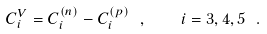<formula> <loc_0><loc_0><loc_500><loc_500>C _ { i } ^ { V } = C _ { i } ^ { ( n ) } - C _ { i } ^ { ( p ) } \ , \quad i = 3 , 4 , 5 \ .</formula> 